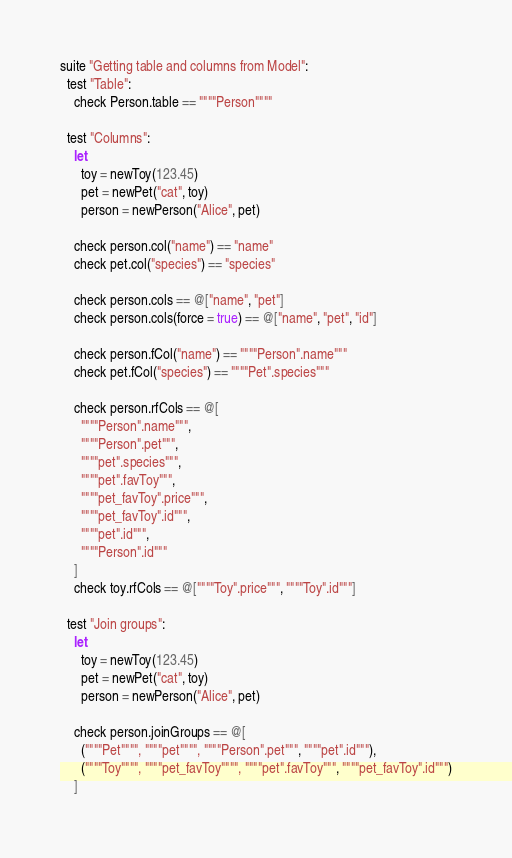Convert code to text. <code><loc_0><loc_0><loc_500><loc_500><_Nim_>

suite "Getting table and columns from Model":
  test "Table":
    check Person.table == """"Person""""

  test "Columns":
    let
      toy = newToy(123.45)
      pet = newPet("cat", toy)
      person = newPerson("Alice", pet)

    check person.col("name") == "name"
    check pet.col("species") == "species"

    check person.cols == @["name", "pet"]
    check person.cols(force = true) == @["name", "pet", "id"]

    check person.fCol("name") == """"Person".name"""
    check pet.fCol("species") == """"Pet".species"""

    check person.rfCols == @[
      """"Person".name""",
      """"Person".pet""",
      """"pet".species""",
      """"pet".favToy""",
      """"pet_favToy".price""",
      """"pet_favToy".id""",
      """"pet".id""",
      """"Person".id"""
    ]
    check toy.rfCols == @[""""Toy".price""", """"Toy".id"""]

  test "Join groups":
    let
      toy = newToy(123.45)
      pet = newPet("cat", toy)
      person = newPerson("Alice", pet)

    check person.joinGroups == @[
      (""""Pet"""", """"pet"""", """"Person".pet""", """"pet".id"""),
      (""""Toy"""", """"pet_favToy"""", """"pet".favToy""", """"pet_favToy".id""")
    ]
</code> 